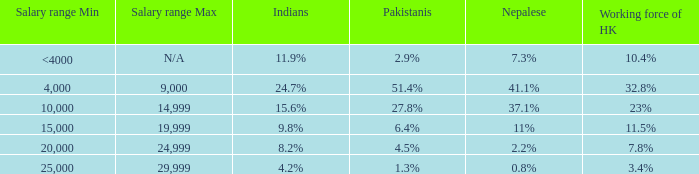If the working force of HK is 32.8%, what are the Pakistanis' %?  51.4%. 